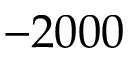<formula> <loc_0><loc_0><loc_500><loc_500>- 2 0 0 0</formula> 